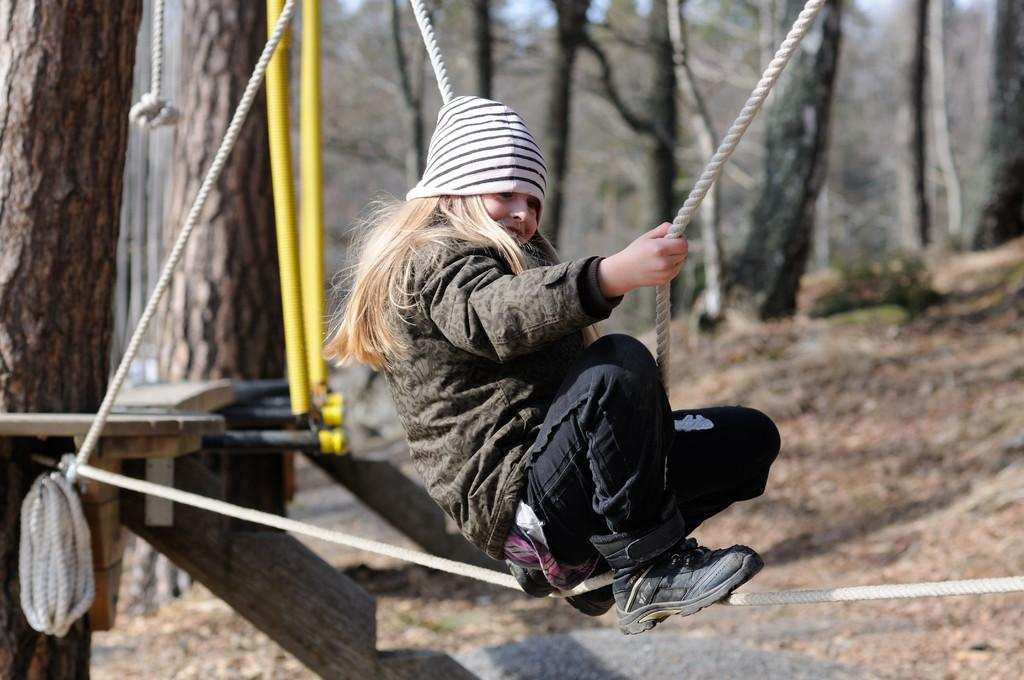Who is the main subject in the image? There is a little girl in the image. What is the girl doing in the image? The girl is swinging on a rope. What can be seen in the background of the image? The background of the image is blurry. What type of environment is the girl in? There are trees surrounding the girl, suggesting a natural setting. What type of haircut does the girl have in the image? The provided facts do not mention the girl's haircut, so it cannot be determined from the image. Can you describe the clouds in the image? There are no clouds visible in the image; the background is blurry. 